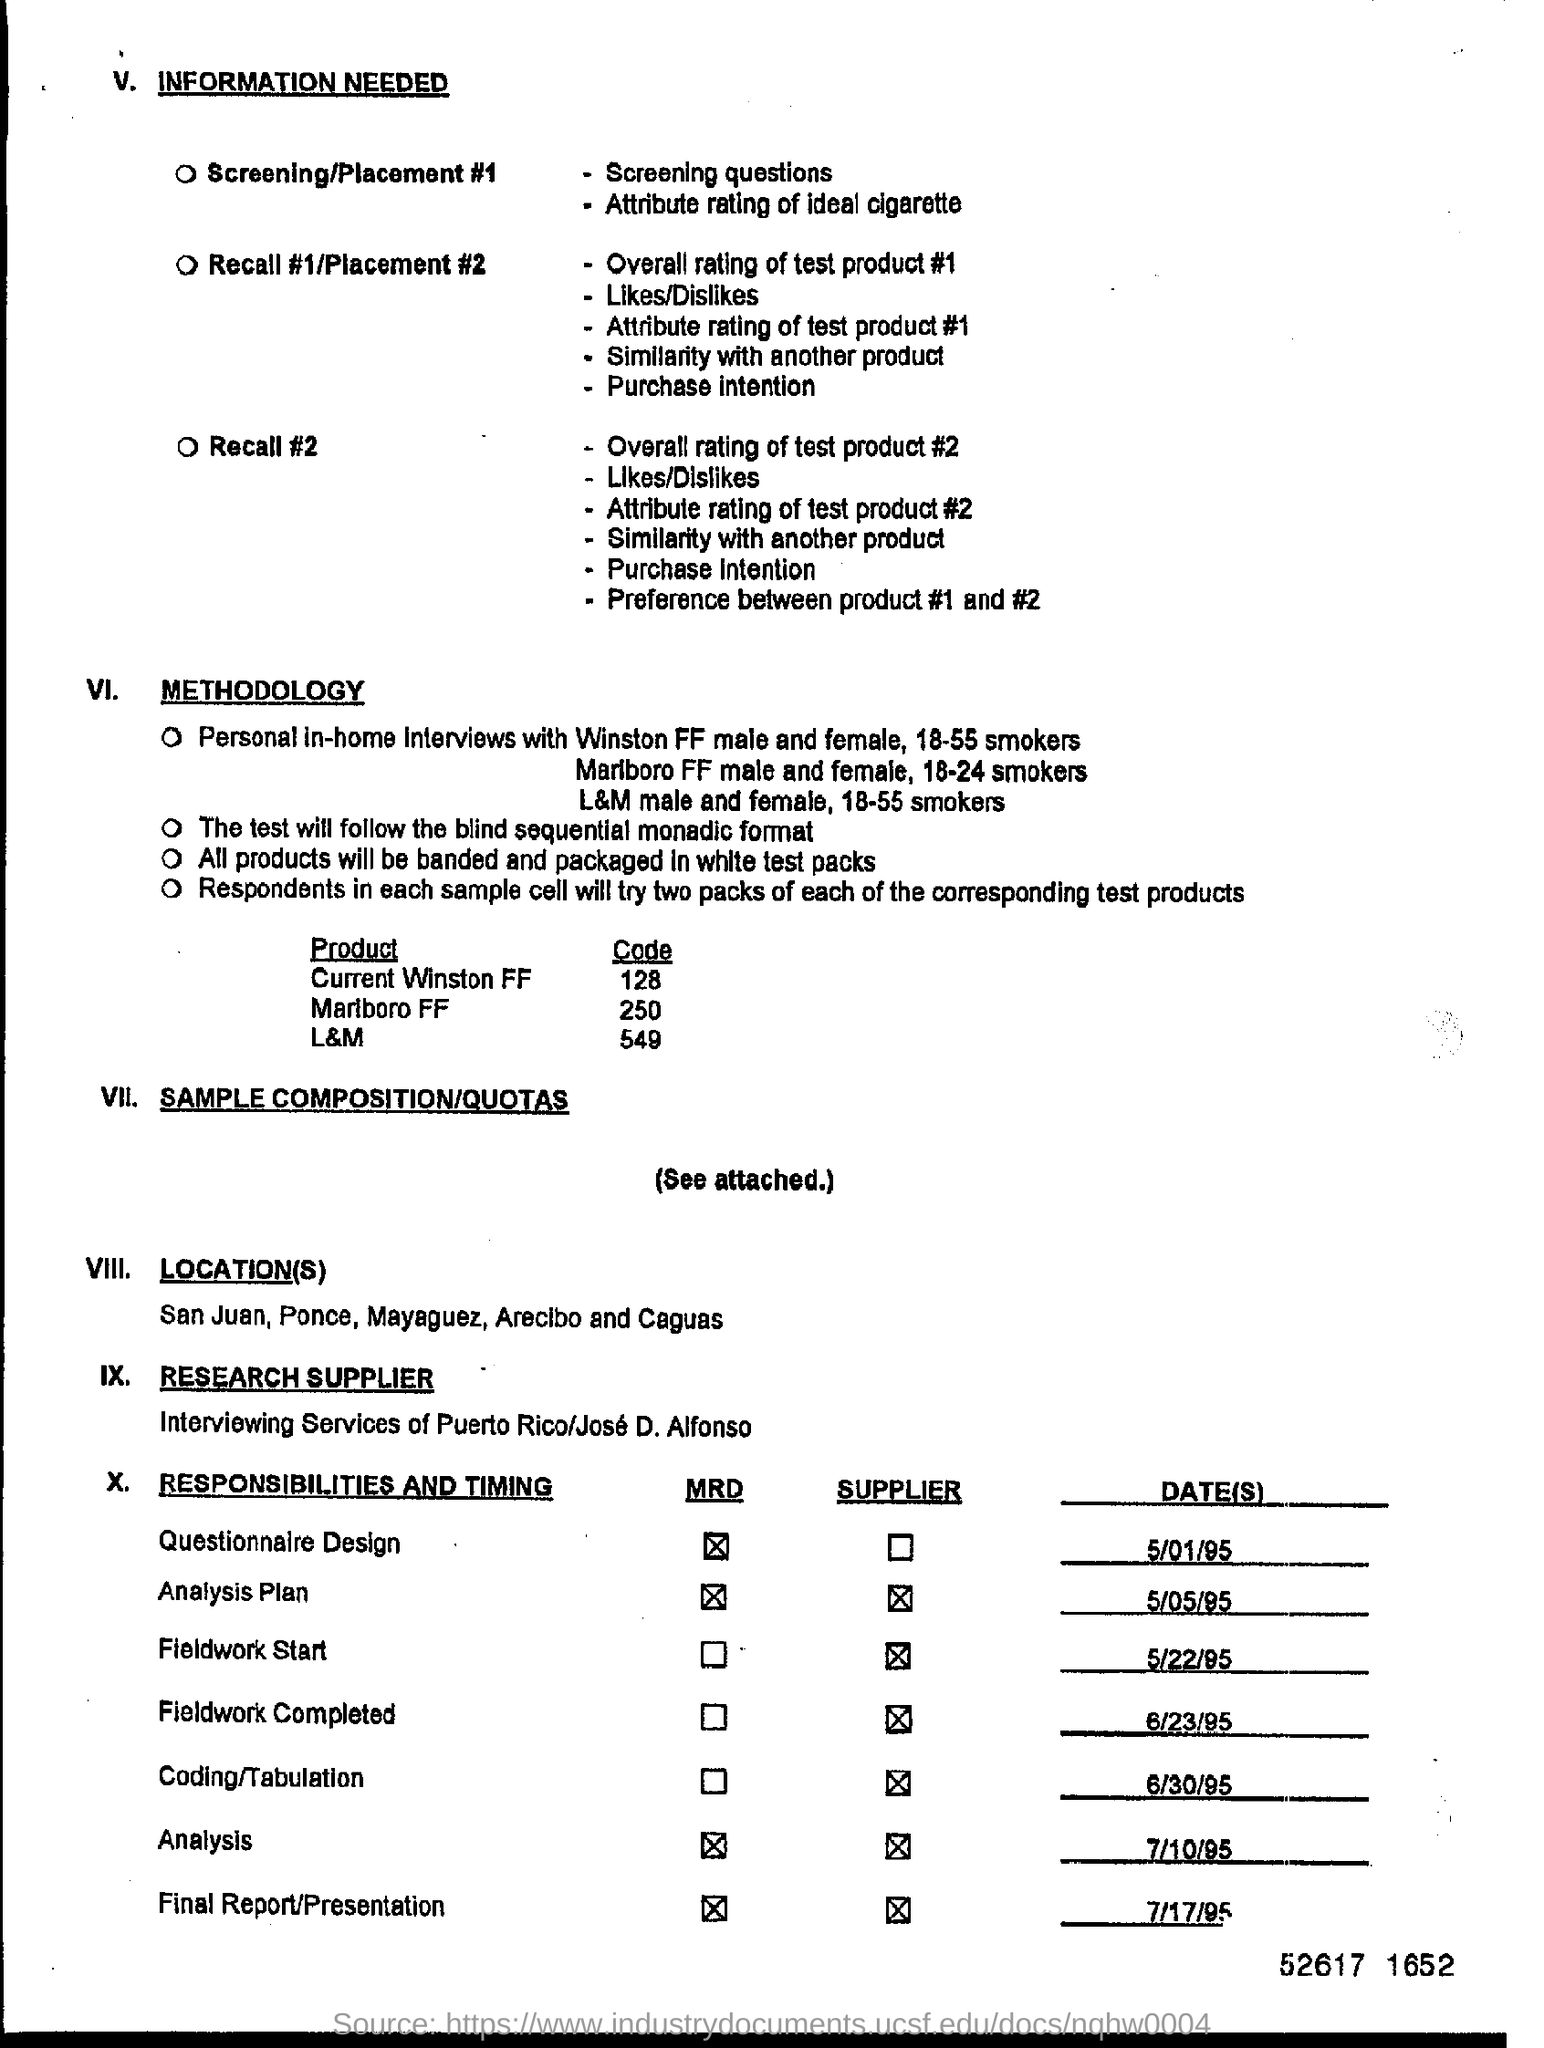Specify some key components in this picture. The question is asking for the code for a product called "Current Winston FF" with a size of 128. July 17, 1995, is the specified date for the final report/presentation. 